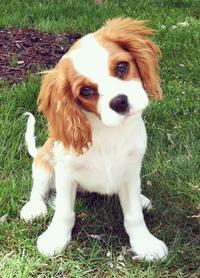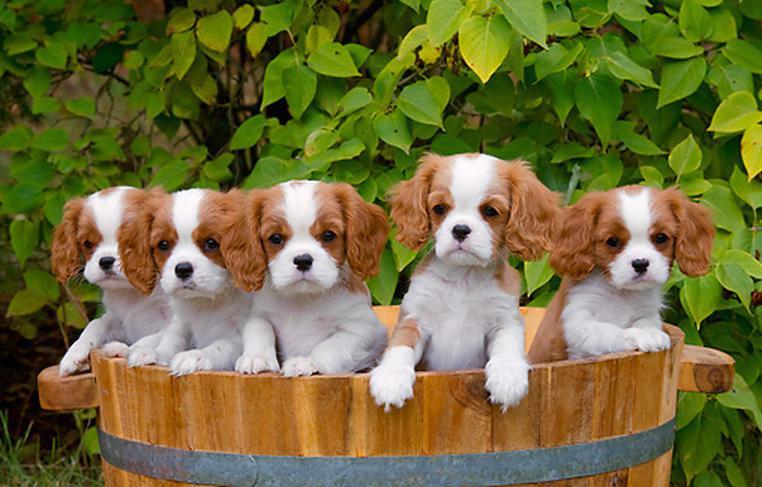The first image is the image on the left, the second image is the image on the right. For the images shown, is this caption "The left image contains at least three dogs." true? Answer yes or no. No. The first image is the image on the left, the second image is the image on the right. Assess this claim about the two images: "In the left image, there is no less than two dogs in a woven basket, and in the right image there is a single brown and white dog". Correct or not? Answer yes or no. No. 